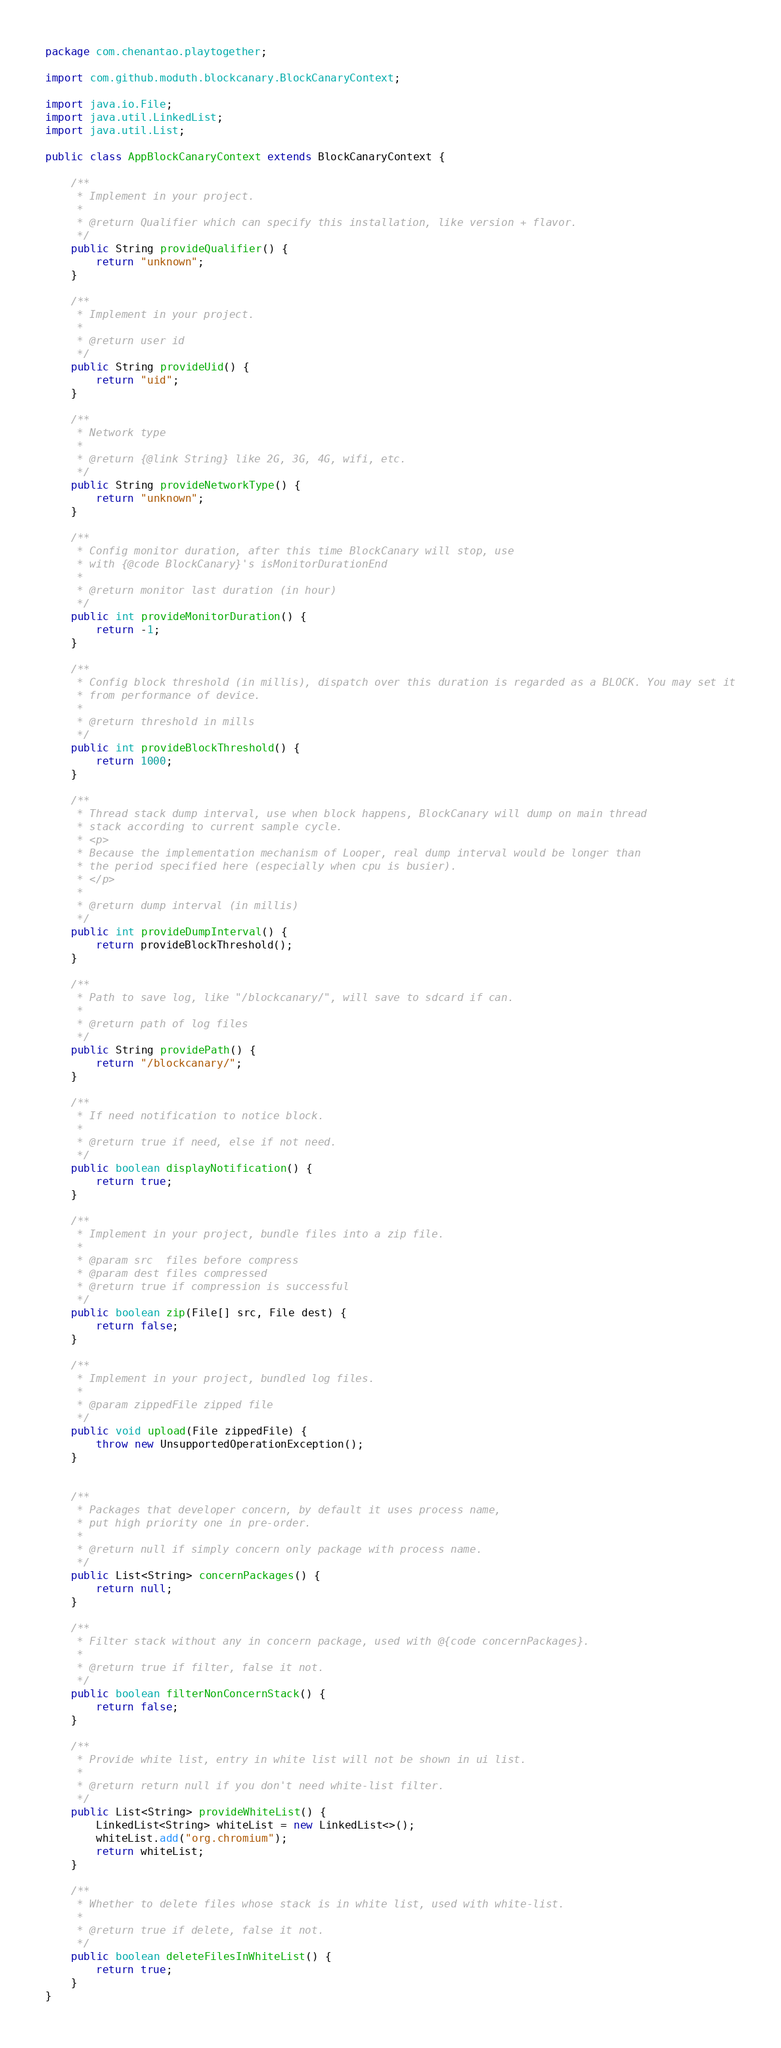<code> <loc_0><loc_0><loc_500><loc_500><_Java_>package com.chenantao.playtogether;

import com.github.moduth.blockcanary.BlockCanaryContext;

import java.io.File;
import java.util.LinkedList;
import java.util.List;

public class AppBlockCanaryContext extends BlockCanaryContext {

    /**
     * Implement in your project.
     *
     * @return Qualifier which can specify this installation, like version + flavor.
     */
    public String provideQualifier() {
        return "unknown";
    }

    /**
     * Implement in your project.
     *
     * @return user id
     */
    public String provideUid() {
        return "uid";
    }

    /**
     * Network type
     *
     * @return {@link String} like 2G, 3G, 4G, wifi, etc.
     */
    public String provideNetworkType() {
        return "unknown";
    }

    /**
     * Config monitor duration, after this time BlockCanary will stop, use
     * with {@code BlockCanary}'s isMonitorDurationEnd
     *
     * @return monitor last duration (in hour)
     */
    public int provideMonitorDuration() {
        return -1;
    }

    /**
     * Config block threshold (in millis), dispatch over this duration is regarded as a BLOCK. You may set it
     * from performance of device.
     *
     * @return threshold in mills
     */
    public int provideBlockThreshold() {
        return 1000;
    }

    /**
     * Thread stack dump interval, use when block happens, BlockCanary will dump on main thread
     * stack according to current sample cycle.
     * <p>
     * Because the implementation mechanism of Looper, real dump interval would be longer than
     * the period specified here (especially when cpu is busier).
     * </p>
     *
     * @return dump interval (in millis)
     */
    public int provideDumpInterval() {
        return provideBlockThreshold();
    }

    /**
     * Path to save log, like "/blockcanary/", will save to sdcard if can.
     *
     * @return path of log files
     */
    public String providePath() {
        return "/blockcanary/";
    }

    /**
     * If need notification to notice block.
     *
     * @return true if need, else if not need.
     */
    public boolean displayNotification() {
        return true;
    }

    /**
     * Implement in your project, bundle files into a zip file.
     *
     * @param src  files before compress
     * @param dest files compressed
     * @return true if compression is successful
     */
    public boolean zip(File[] src, File dest) {
        return false;
    }

    /**
     * Implement in your project, bundled log files.
     *
     * @param zippedFile zipped file
     */
    public void upload(File zippedFile) {
        throw new UnsupportedOperationException();
    }


    /**
     * Packages that developer concern, by default it uses process name,
     * put high priority one in pre-order.
     *
     * @return null if simply concern only package with process name.
     */
    public List<String> concernPackages() {
        return null;
    }

    /**
     * Filter stack without any in concern package, used with @{code concernPackages}.
     *
     * @return true if filter, false it not.
     */
    public boolean filterNonConcernStack() {
        return false;
    }

    /**
     * Provide white list, entry in white list will not be shown in ui list.
     *
     * @return return null if you don't need white-list filter.
     */
    public List<String> provideWhiteList() {
        LinkedList<String> whiteList = new LinkedList<>();
        whiteList.add("org.chromium");
        return whiteList;
    }

    /**
     * Whether to delete files whose stack is in white list, used with white-list.
     *
     * @return true if delete, false it not.
     */
    public boolean deleteFilesInWhiteList() {
        return true;
    }
}</code> 